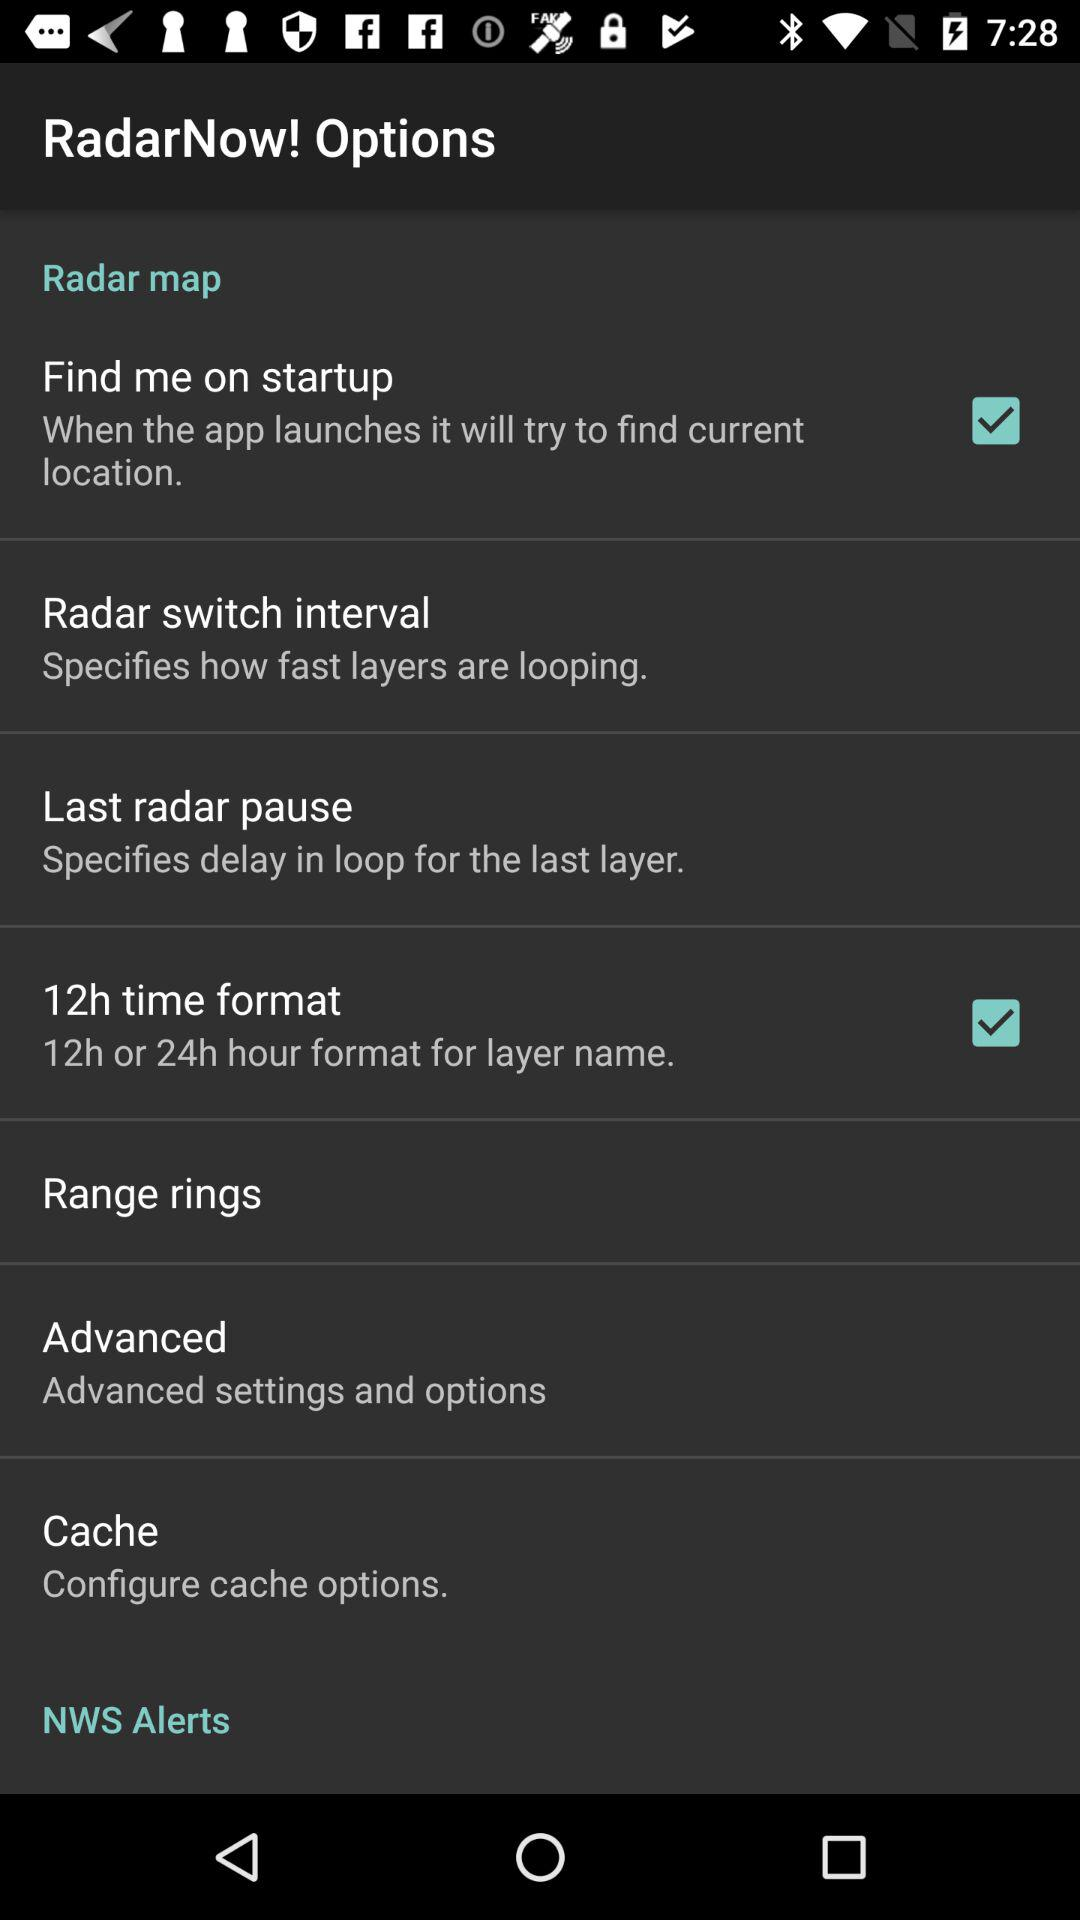What is the status of "Find me on startup"? The status is "on". 